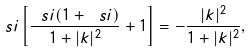Convert formula to latex. <formula><loc_0><loc_0><loc_500><loc_500>\ s i \left [ \frac { \ s i ( 1 + \ s i ) } { 1 + | k | ^ { 2 } } + 1 \right ] = - \frac { | k | ^ { 2 } } { 1 + | k | ^ { 2 } } ,</formula> 